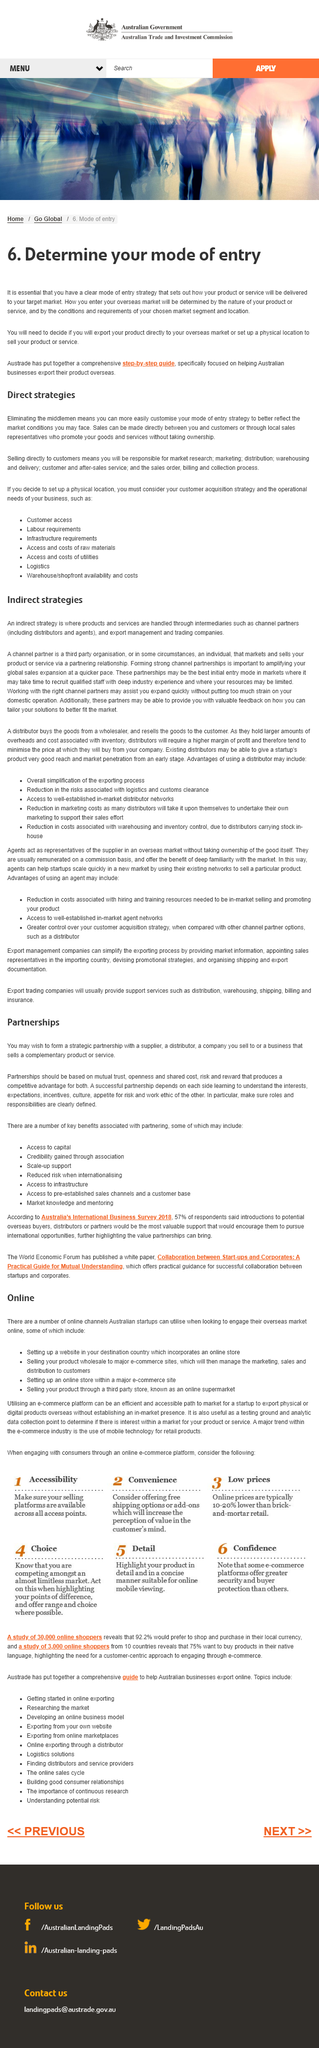Specify some key components in this picture. Yes, deciding whether to export a product directly to the overseas market is an aspect of determining the mode of entry Austrade has developed a comprehensive step-by-step guide for Australian businesses looking to expand into the US market. The step-by-step guide is a comprehensive guide that specifically focuses on assisting Australian businesses in exporting their products overseas. 